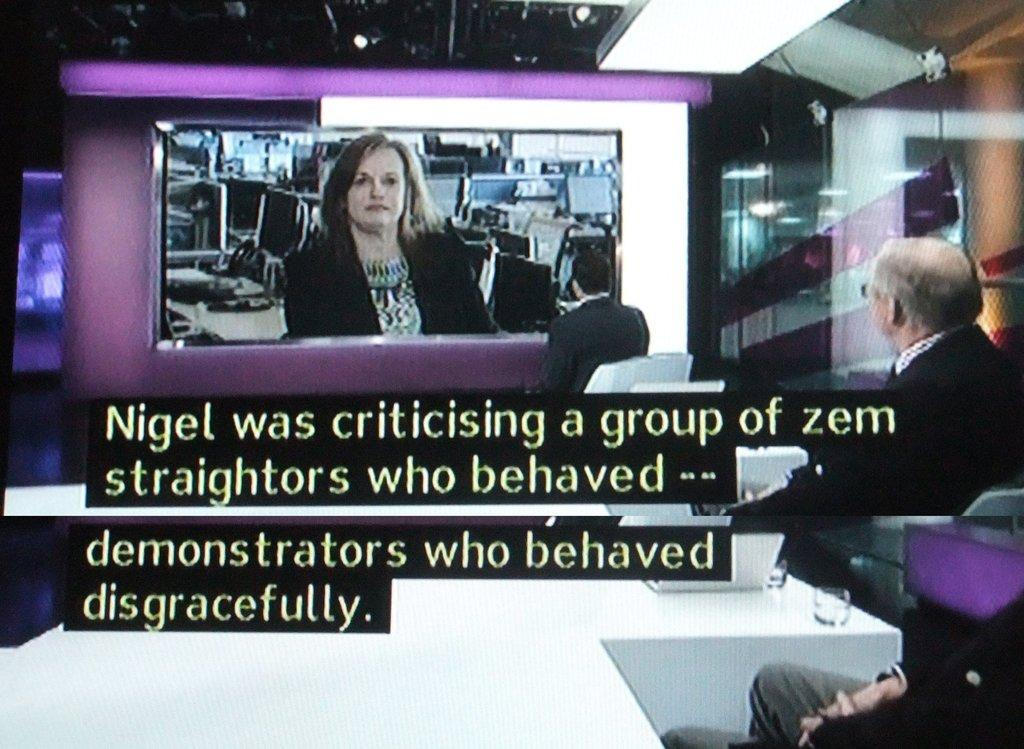<image>
Write a terse but informative summary of the picture. Men watch a television screen which depicts Nigel criticizing a group of Zem demonstrators who behaved disgracefully.t 